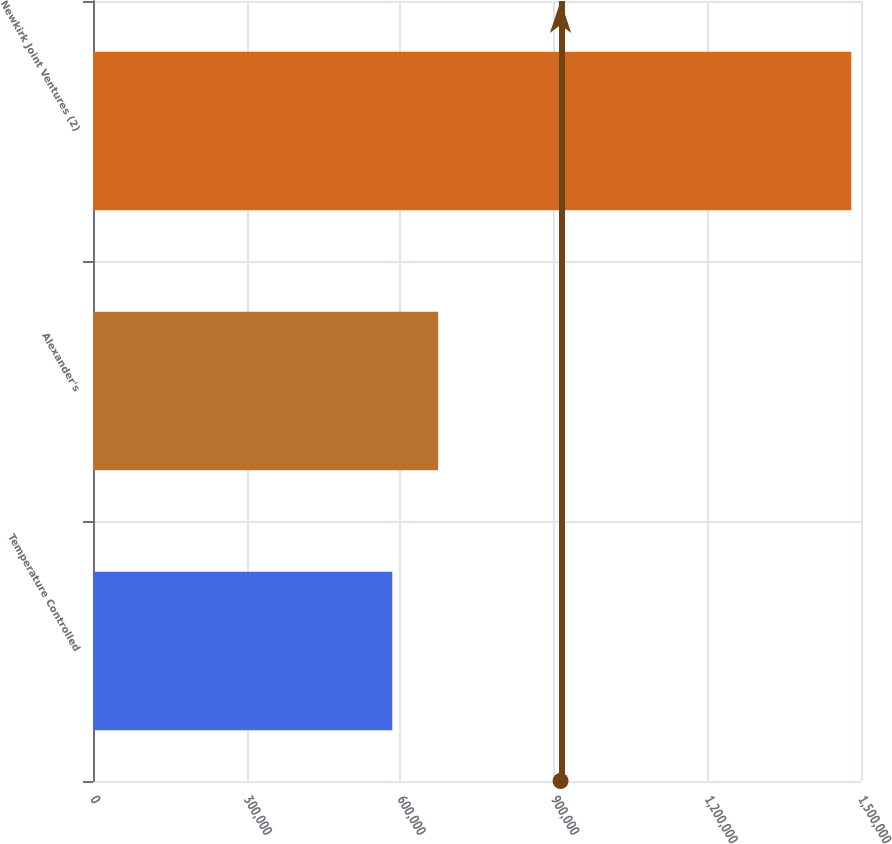<chart> <loc_0><loc_0><loc_500><loc_500><bar_chart><fcel>Temperature Controlled<fcel>Alexander's<fcel>Newkirk Joint Ventures (2)<nl><fcel>584511<fcel>674162<fcel>1.48103e+06<nl></chart> 